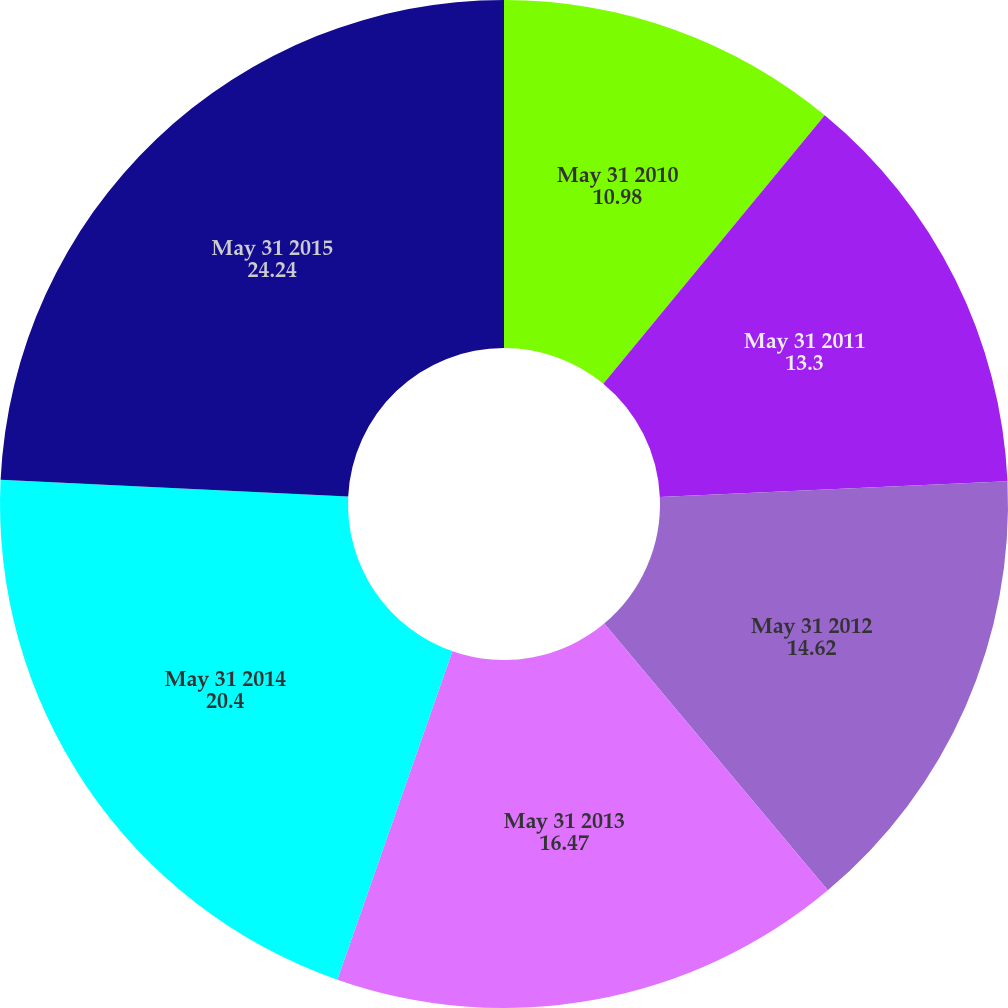Convert chart to OTSL. <chart><loc_0><loc_0><loc_500><loc_500><pie_chart><fcel>May 31 2010<fcel>May 31 2011<fcel>May 31 2012<fcel>May 31 2013<fcel>May 31 2014<fcel>May 31 2015<nl><fcel>10.98%<fcel>13.3%<fcel>14.62%<fcel>16.47%<fcel>20.4%<fcel>24.24%<nl></chart> 